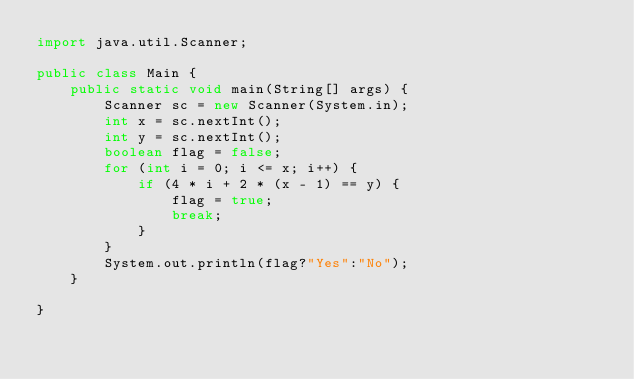Convert code to text. <code><loc_0><loc_0><loc_500><loc_500><_Java_>import java.util.Scanner;

public class Main {
    public static void main(String[] args) {
        Scanner sc = new Scanner(System.in);
        int x = sc.nextInt();
        int y = sc.nextInt();
        boolean flag = false;
        for (int i = 0; i <= x; i++) {
            if (4 * i + 2 * (x - 1) == y) {
                flag = true;
                break;
            }
        }
        System.out.println(flag?"Yes":"No");
    }

}
</code> 